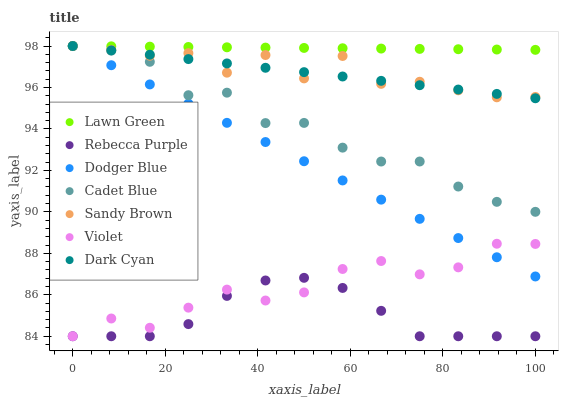Does Rebecca Purple have the minimum area under the curve?
Answer yes or no. Yes. Does Lawn Green have the maximum area under the curve?
Answer yes or no. Yes. Does Cadet Blue have the minimum area under the curve?
Answer yes or no. No. Does Cadet Blue have the maximum area under the curve?
Answer yes or no. No. Is Dark Cyan the smoothest?
Answer yes or no. Yes. Is Sandy Brown the roughest?
Answer yes or no. Yes. Is Cadet Blue the smoothest?
Answer yes or no. No. Is Cadet Blue the roughest?
Answer yes or no. No. Does Rebecca Purple have the lowest value?
Answer yes or no. Yes. Does Cadet Blue have the lowest value?
Answer yes or no. No. Does Sandy Brown have the highest value?
Answer yes or no. Yes. Does Rebecca Purple have the highest value?
Answer yes or no. No. Is Rebecca Purple less than Dark Cyan?
Answer yes or no. Yes. Is Dark Cyan greater than Violet?
Answer yes or no. Yes. Does Dodger Blue intersect Dark Cyan?
Answer yes or no. Yes. Is Dodger Blue less than Dark Cyan?
Answer yes or no. No. Is Dodger Blue greater than Dark Cyan?
Answer yes or no. No. Does Rebecca Purple intersect Dark Cyan?
Answer yes or no. No. 